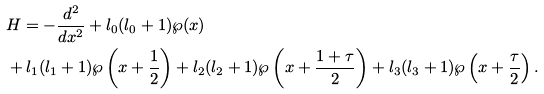Convert formula to latex. <formula><loc_0><loc_0><loc_500><loc_500>& H = - \frac { d ^ { 2 } } { d x ^ { 2 } } + l _ { 0 } ( l _ { 0 } + 1 ) \wp ( x ) \\ & + l _ { 1 } ( l _ { 1 } + 1 ) \wp \left ( x + \frac { 1 } { 2 } \right ) + l _ { 2 } ( l _ { 2 } + 1 ) \wp \left ( x + \frac { 1 + \tau } { 2 } \right ) + l _ { 3 } ( l _ { 3 } + 1 ) \wp \left ( x + \frac { \tau } { 2 } \right ) .</formula> 